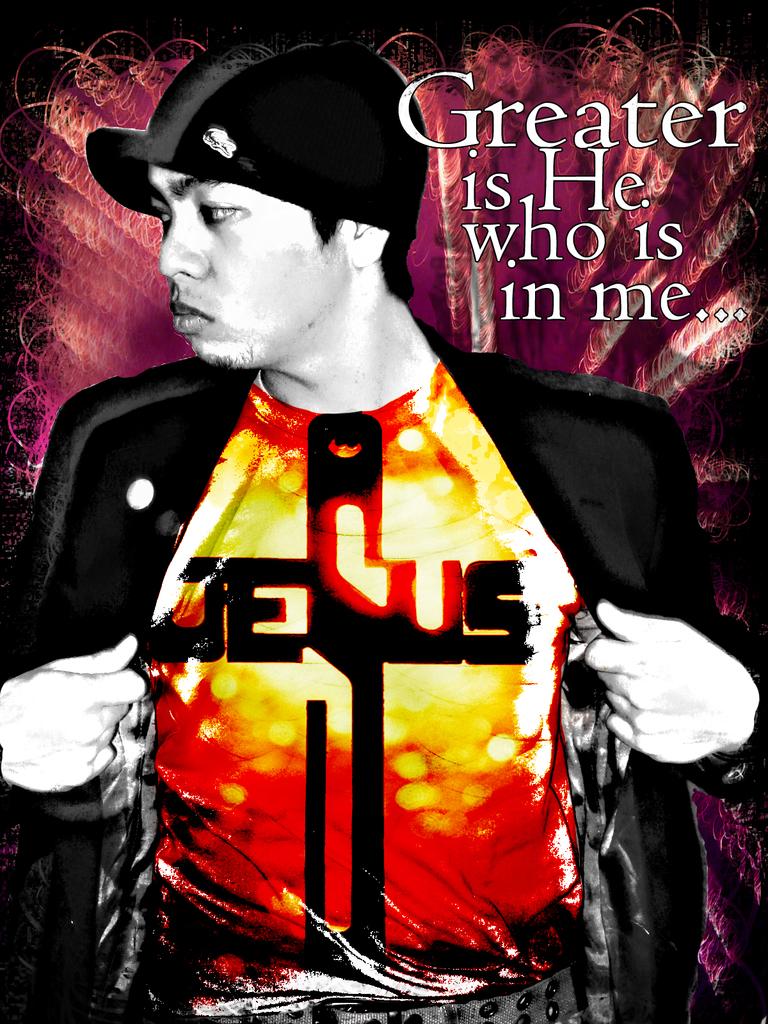What does it say on the mans chest?
Give a very brief answer. Jesus. What word is the top big word?
Your answer should be very brief. Greater. 